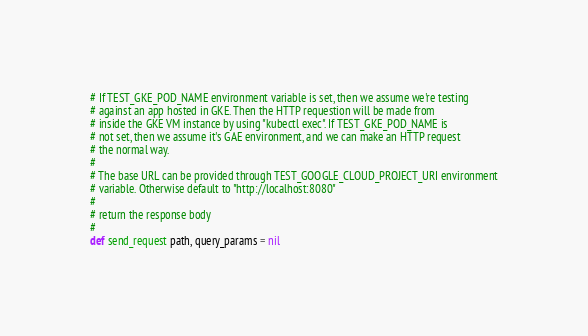<code> <loc_0><loc_0><loc_500><loc_500><_Ruby_># If TEST_GKE_POD_NAME environment variable is set, then we assume we're testing
# against an app hosted in GKE. Then the HTTP requestion will be made from
# inside the GKE VM instance by using "kubectl exec". If TEST_GKE_POD_NAME is
# not set, then we assume it's GAE environment, and we can make an HTTP request
# the normal way.
#
# The base URL can be provided through TEST_GOOGLE_CLOUD_PROJECT_URI environment
# variable. Otherwise default to "http://localhost:8080"
#
# return the response body
#
def send_request path, query_params = nil</code> 